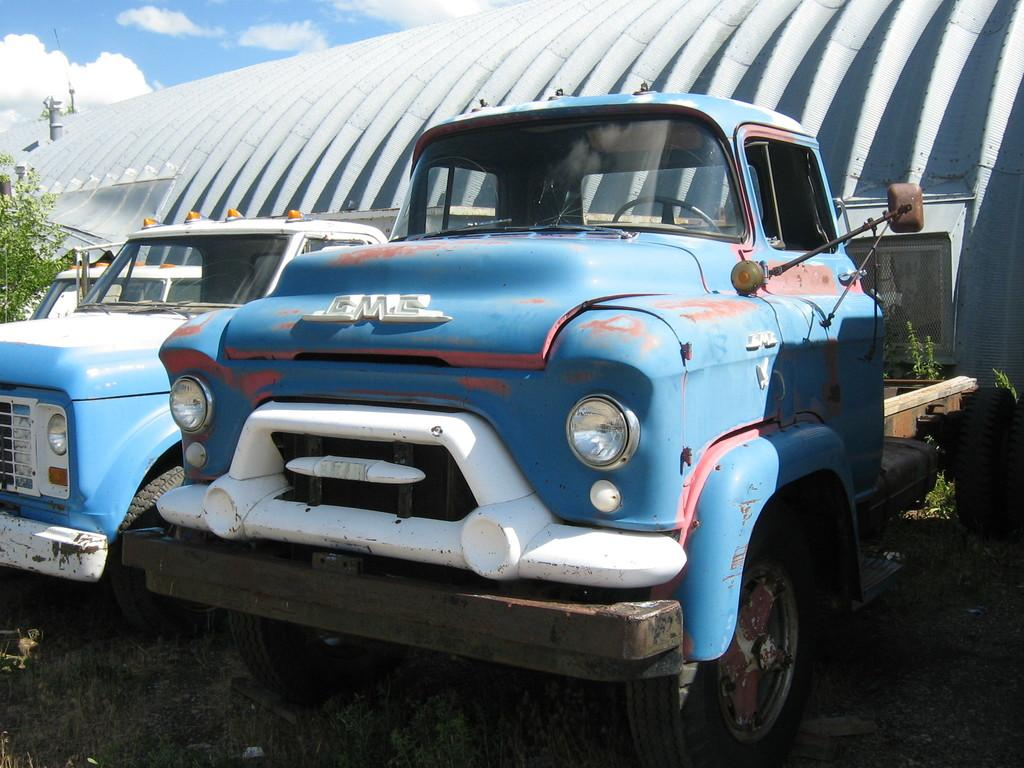What is located in the middle of the image? There is a possible building in the middle of the image. What can be seen in front of the building? There are vehicles in front of the building. What type of vegetation is visible in the image? There are plants visible in the image. What is visible at the top of the image? The sky is visible at the top of the image. What answer can be seen written on the knee of the person in the image? There is no person present in the image, and therefore no answer written on their knee. 